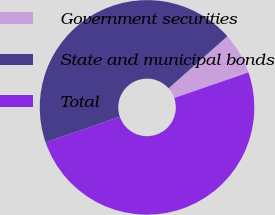<chart> <loc_0><loc_0><loc_500><loc_500><pie_chart><fcel>Government securities<fcel>State and municipal bonds<fcel>Total<nl><fcel>6.25%<fcel>43.75%<fcel>50.0%<nl></chart> 